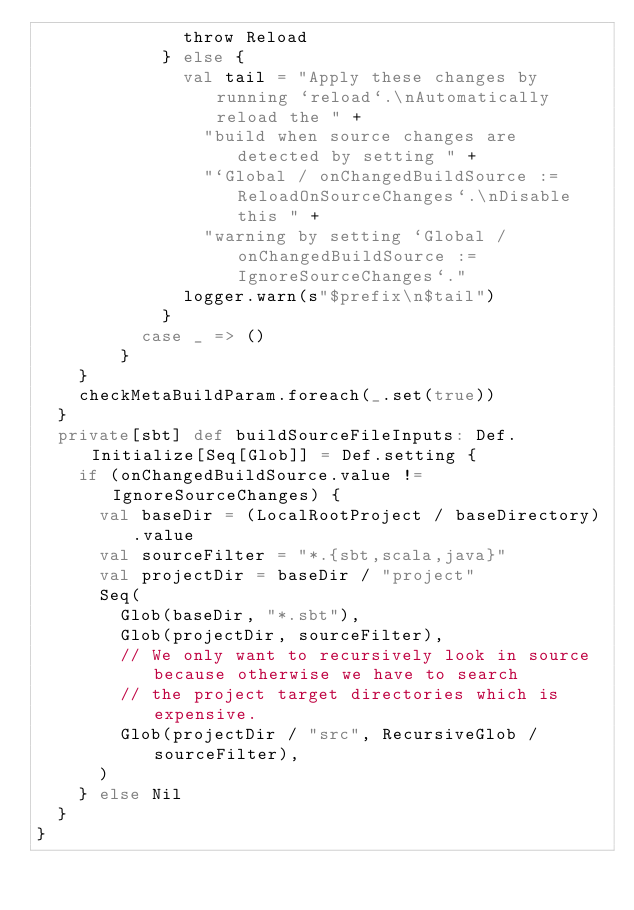<code> <loc_0><loc_0><loc_500><loc_500><_Scala_>              throw Reload
            } else {
              val tail = "Apply these changes by running `reload`.\nAutomatically reload the " +
                "build when source changes are detected by setting " +
                "`Global / onChangedBuildSource := ReloadOnSourceChanges`.\nDisable this " +
                "warning by setting `Global / onChangedBuildSource := IgnoreSourceChanges`."
              logger.warn(s"$prefix\n$tail")
            }
          case _ => ()
        }
    }
    checkMetaBuildParam.foreach(_.set(true))
  }
  private[sbt] def buildSourceFileInputs: Def.Initialize[Seq[Glob]] = Def.setting {
    if (onChangedBuildSource.value != IgnoreSourceChanges) {
      val baseDir = (LocalRootProject / baseDirectory).value
      val sourceFilter = "*.{sbt,scala,java}"
      val projectDir = baseDir / "project"
      Seq(
        Glob(baseDir, "*.sbt"),
        Glob(projectDir, sourceFilter),
        // We only want to recursively look in source because otherwise we have to search
        // the project target directories which is expensive.
        Glob(projectDir / "src", RecursiveGlob / sourceFilter),
      )
    } else Nil
  }
}
</code> 